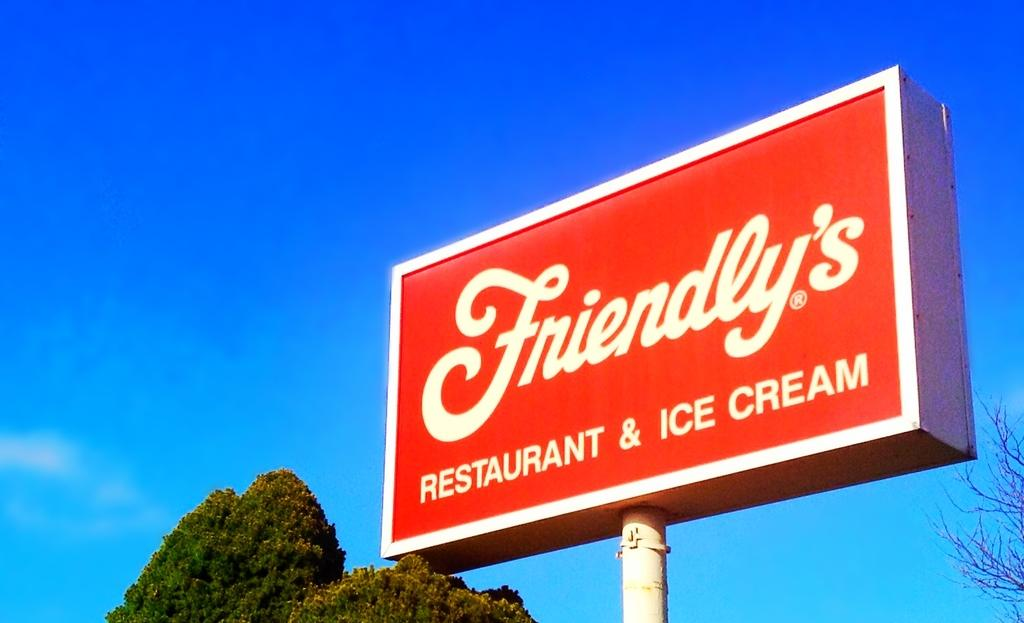<image>
Present a compact description of the photo's key features. The sign is from Friendly's RESTAURANT AND ICE CREAM place. 